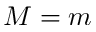<formula> <loc_0><loc_0><loc_500><loc_500>M = m</formula> 